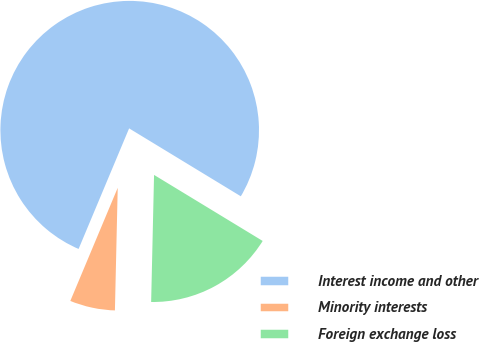Convert chart. <chart><loc_0><loc_0><loc_500><loc_500><pie_chart><fcel>Interest income and other<fcel>Minority interests<fcel>Foreign exchange loss<nl><fcel>77.38%<fcel>5.95%<fcel>16.67%<nl></chart> 